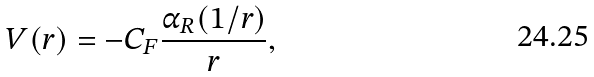Convert formula to latex. <formula><loc_0><loc_0><loc_500><loc_500>V ( r ) = - C _ { F } \frac { \alpha _ { R } ( 1 / r ) } { r } ,</formula> 